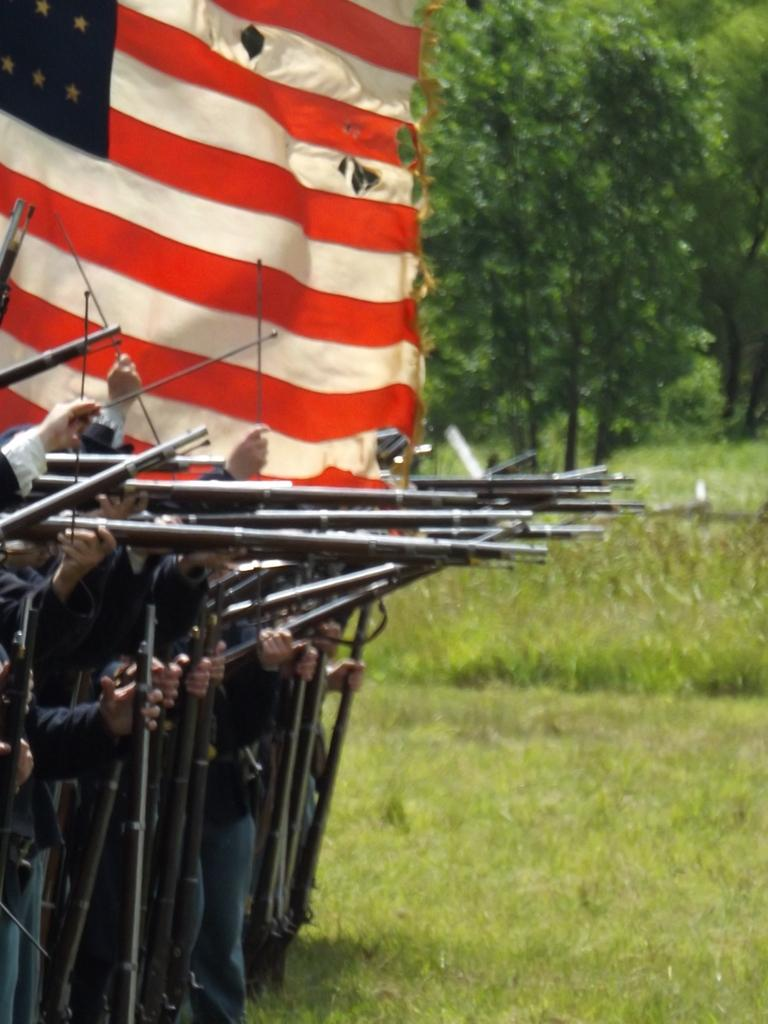What can be seen on the left side of the image? There are soldiers holding guns on the left side of the image. What symbol or emblem is present in the image? There is a flag in the image. What type of vegetation is visible in the background of the image? There are trees, shrubs, and grass in the background of the image. What type of cream is being used to treat the soldier's stomach in the image? There is no mention of cream or any medical treatment in the image; it features soldiers holding guns and a flag. What type of system is being used by the soldiers to communicate in the image? The image does not show any communication system being used by the soldiers; they are simply holding guns. 